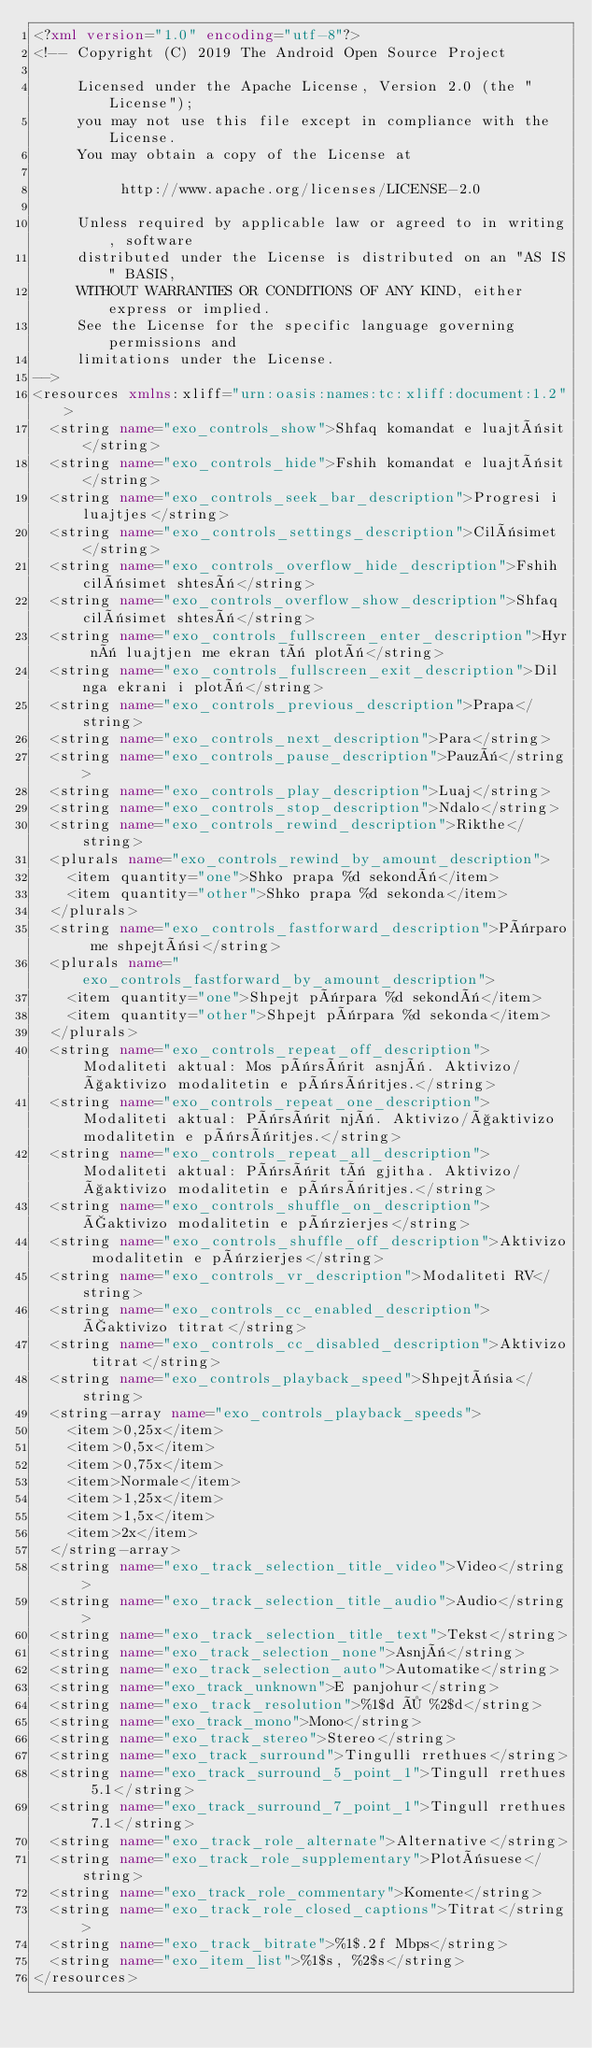<code> <loc_0><loc_0><loc_500><loc_500><_XML_><?xml version="1.0" encoding="utf-8"?>
<!-- Copyright (C) 2019 The Android Open Source Project

     Licensed under the Apache License, Version 2.0 (the "License");
     you may not use this file except in compliance with the License.
     You may obtain a copy of the License at

          http://www.apache.org/licenses/LICENSE-2.0

     Unless required by applicable law or agreed to in writing, software
     distributed under the License is distributed on an "AS IS" BASIS,
     WITHOUT WARRANTIES OR CONDITIONS OF ANY KIND, either express or implied.
     See the License for the specific language governing permissions and
     limitations under the License.
-->
<resources xmlns:xliff="urn:oasis:names:tc:xliff:document:1.2">
  <string name="exo_controls_show">Shfaq komandat e luajtësit</string>
  <string name="exo_controls_hide">Fshih komandat e luajtësit</string>
  <string name="exo_controls_seek_bar_description">Progresi i luajtjes</string>
  <string name="exo_controls_settings_description">Cilësimet</string>
  <string name="exo_controls_overflow_hide_description">Fshih cilësimet shtesë</string>
  <string name="exo_controls_overflow_show_description">Shfaq cilësimet shtesë</string>
  <string name="exo_controls_fullscreen_enter_description">Hyr në luajtjen me ekran të plotë</string>
  <string name="exo_controls_fullscreen_exit_description">Dil nga ekrani i plotë</string>
  <string name="exo_controls_previous_description">Prapa</string>
  <string name="exo_controls_next_description">Para</string>
  <string name="exo_controls_pause_description">Pauzë</string>
  <string name="exo_controls_play_description">Luaj</string>
  <string name="exo_controls_stop_description">Ndalo</string>
  <string name="exo_controls_rewind_description">Rikthe</string>
  <plurals name="exo_controls_rewind_by_amount_description">
    <item quantity="one">Shko prapa %d sekondë</item>
    <item quantity="other">Shko prapa %d sekonda</item>
  </plurals>
  <string name="exo_controls_fastforward_description">Përparo me shpejtësi</string>
  <plurals name="exo_controls_fastforward_by_amount_description">
    <item quantity="one">Shpejt përpara %d sekondë</item>
    <item quantity="other">Shpejt përpara %d sekonda</item>
  </plurals>
  <string name="exo_controls_repeat_off_description">Modaliteti aktual: Mos përsërit asnjë. Aktivizo/çaktivizo modalitetin e përsëritjes.</string>
  <string name="exo_controls_repeat_one_description">Modaliteti aktual: Përsërit një. Aktivizo/çaktivizo modalitetin e përsëritjes.</string>
  <string name="exo_controls_repeat_all_description">Modaliteti aktual: Përsërit të gjitha. Aktivizo/çaktivizo modalitetin e përsëritjes.</string>
  <string name="exo_controls_shuffle_on_description">Çaktivizo modalitetin e përzierjes</string>
  <string name="exo_controls_shuffle_off_description">Aktivizo modalitetin e përzierjes</string>
  <string name="exo_controls_vr_description">Modaliteti RV</string>
  <string name="exo_controls_cc_enabled_description">Çaktivizo titrat</string>
  <string name="exo_controls_cc_disabled_description">Aktivizo titrat</string>
  <string name="exo_controls_playback_speed">Shpejtësia</string>
  <string-array name="exo_controls_playback_speeds">
    <item>0,25x</item>
    <item>0,5x</item>
    <item>0,75x</item>
    <item>Normale</item>
    <item>1,25x</item>
    <item>1,5x</item>
    <item>2x</item>
  </string-array>
  <string name="exo_track_selection_title_video">Video</string>
  <string name="exo_track_selection_title_audio">Audio</string>
  <string name="exo_track_selection_title_text">Tekst</string>
  <string name="exo_track_selection_none">Asnjë</string>
  <string name="exo_track_selection_auto">Automatike</string>
  <string name="exo_track_unknown">E panjohur</string>
  <string name="exo_track_resolution">%1$d × %2$d</string>
  <string name="exo_track_mono">Mono</string>
  <string name="exo_track_stereo">Stereo</string>
  <string name="exo_track_surround">Tingulli rrethues</string>
  <string name="exo_track_surround_5_point_1">Tingull rrethues 5.1</string>
  <string name="exo_track_surround_7_point_1">Tingull rrethues 7.1</string>
  <string name="exo_track_role_alternate">Alternative</string>
  <string name="exo_track_role_supplementary">Plotësuese</string>
  <string name="exo_track_role_commentary">Komente</string>
  <string name="exo_track_role_closed_captions">Titrat</string>
  <string name="exo_track_bitrate">%1$.2f Mbps</string>
  <string name="exo_item_list">%1$s, %2$s</string>
</resources>
</code> 